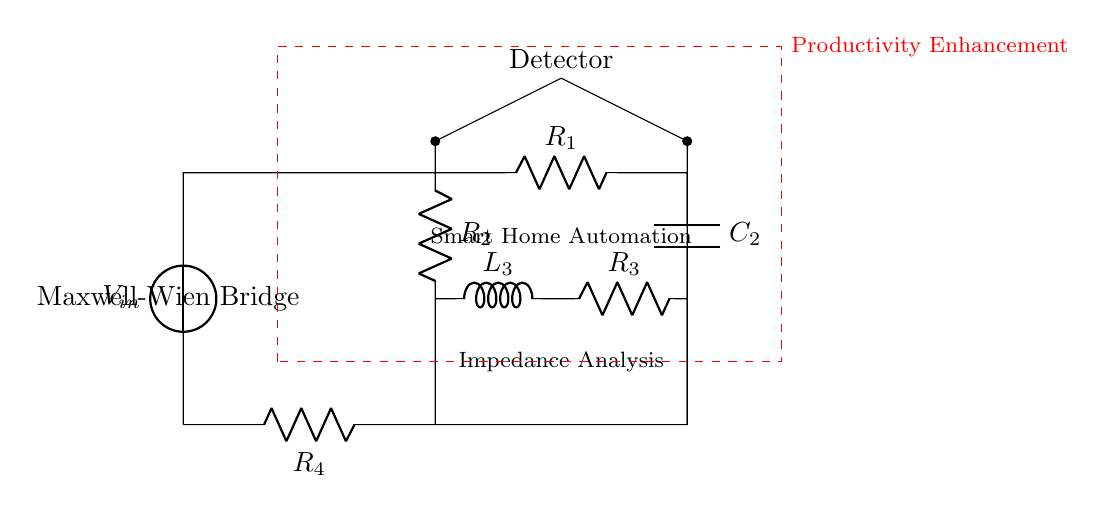What kind of bridge is depicted in the diagram? The diagram shows a Maxwell-Wien bridge, which is specifically designed for analyzing complex impedance. The label within the circuit clearly denotes it as a Maxwell-Wien Bridge.
Answer: Maxwell-Wien bridge What components are included in this circuit? The circuit diagram includes resistors, a capacitor, an inductor, and a voltage source. These components are labeled in the diagram, indicating their roles in the impedance analysis.
Answer: Resistors, capacitor, inductor, voltage source What does the label “Smart Home Automation” suggest? The label indicates that this circuit is intended to be used within smart home automation systems, pointing to its application area in enhancing automation experiences.
Answer: Application in smart home automation How many resistors are present in the circuit? There are three resistors indicated in the circuit: R1, R2, and R3. The specific labels and placements identify each resistor within the Maxwell-Wien bridge.
Answer: Three resistors What role does the capacitor play in this circuit? The capacitor serves to modify the phase and magnitude of the impedance, which is crucial for accurate impedance analysis. Its presence helps facilitate the complex impedance measurements.
Answer: Modifies phase and magnitude of impedance What does the "Productivity Enhancement" rectangle represent? The rectangle signifies that the overall purpose of this Maxwell-Wien bridge circuit is directed towards improving productivity, suggesting its application context or benefits in real-world usage scenarios.
Answer: Purpose for productivity enhancement What type of analysis can be performed with this circuit? The circuit allows for complex impedance analysis, which is essential in understanding how components respond to various frequencies and to optimize system performance in applications like smart home automation.
Answer: Complex impedance analysis 